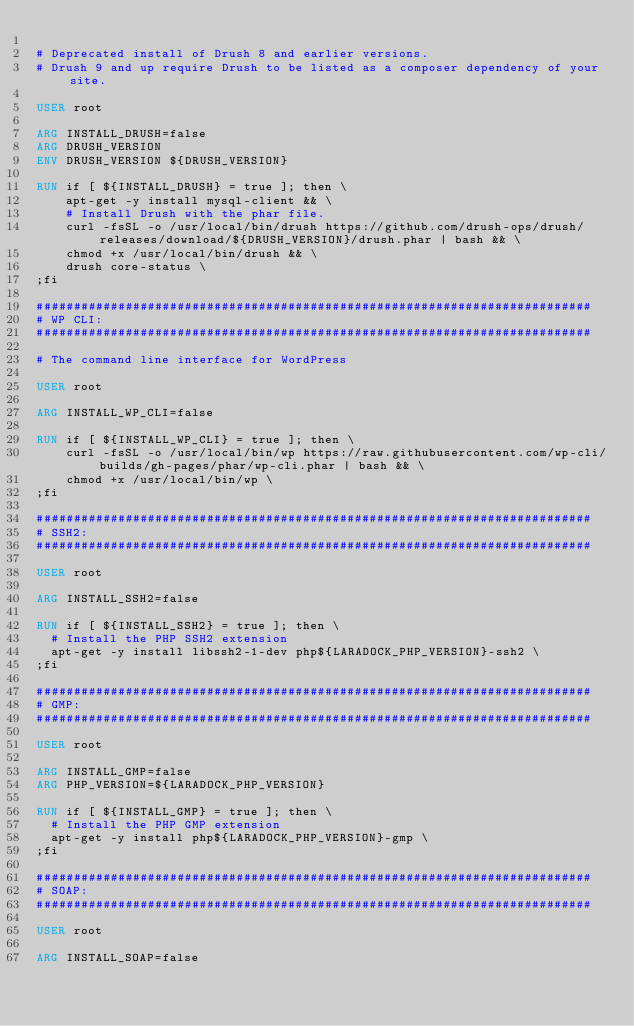Convert code to text. <code><loc_0><loc_0><loc_500><loc_500><_Dockerfile_>
# Deprecated install of Drush 8 and earlier versions.
# Drush 9 and up require Drush to be listed as a composer dependency of your site.

USER root

ARG INSTALL_DRUSH=false
ARG DRUSH_VERSION
ENV DRUSH_VERSION ${DRUSH_VERSION}

RUN if [ ${INSTALL_DRUSH} = true ]; then \
    apt-get -y install mysql-client && \
    # Install Drush with the phar file.
    curl -fsSL -o /usr/local/bin/drush https://github.com/drush-ops/drush/releases/download/${DRUSH_VERSION}/drush.phar | bash && \
    chmod +x /usr/local/bin/drush && \
    drush core-status \
;fi

###########################################################################
# WP CLI:
###########################################################################

# The command line interface for WordPress

USER root

ARG INSTALL_WP_CLI=false

RUN if [ ${INSTALL_WP_CLI} = true ]; then \
    curl -fsSL -o /usr/local/bin/wp https://raw.githubusercontent.com/wp-cli/builds/gh-pages/phar/wp-cli.phar | bash && \
    chmod +x /usr/local/bin/wp \
;fi

###########################################################################
# SSH2:
###########################################################################

USER root

ARG INSTALL_SSH2=false

RUN if [ ${INSTALL_SSH2} = true ]; then \
  # Install the PHP SSH2 extension
  apt-get -y install libssh2-1-dev php${LARADOCK_PHP_VERSION}-ssh2 \
;fi

###########################################################################
# GMP:
###########################################################################

USER root

ARG INSTALL_GMP=false
ARG PHP_VERSION=${LARADOCK_PHP_VERSION}

RUN if [ ${INSTALL_GMP} = true ]; then \
  # Install the PHP GMP extension
  apt-get -y install php${LARADOCK_PHP_VERSION}-gmp \
;fi

###########################################################################
# SOAP:
###########################################################################

USER root

ARG INSTALL_SOAP=false
</code> 